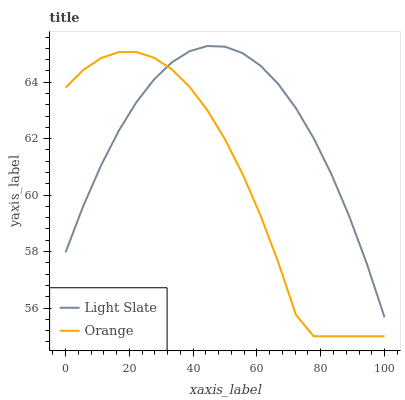Does Orange have the minimum area under the curve?
Answer yes or no. Yes. Does Light Slate have the maximum area under the curve?
Answer yes or no. Yes. Does Orange have the maximum area under the curve?
Answer yes or no. No. Is Light Slate the smoothest?
Answer yes or no. Yes. Is Orange the roughest?
Answer yes or no. Yes. Is Orange the smoothest?
Answer yes or no. No. Does Orange have the lowest value?
Answer yes or no. Yes. Does Light Slate have the highest value?
Answer yes or no. Yes. Does Orange have the highest value?
Answer yes or no. No. Does Orange intersect Light Slate?
Answer yes or no. Yes. Is Orange less than Light Slate?
Answer yes or no. No. Is Orange greater than Light Slate?
Answer yes or no. No. 